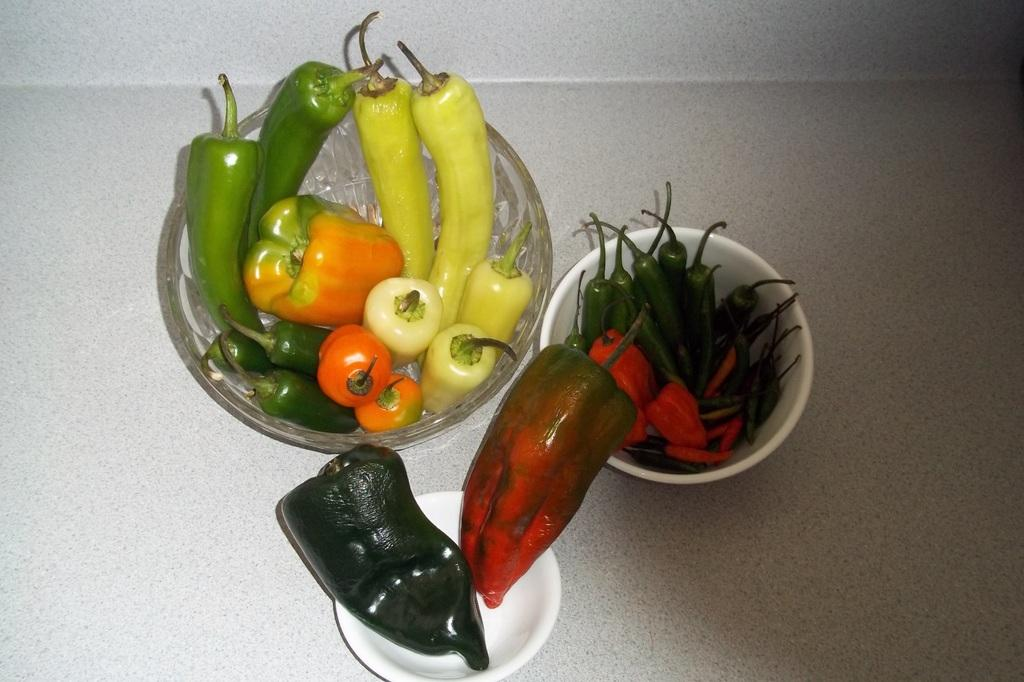What type of bowls are visible in the image? There is a glass bowl and two ceramic bowls in the image. What is the surface that the bowls are placed on? The bowls are on a marble table. What is inside the bowls? Green chilies are present in the bowls. How many ladybugs can be seen crawling on the hall in the image? There are no ladybugs or halls present in the image; it features bowls on a marble table with green chilies inside. 